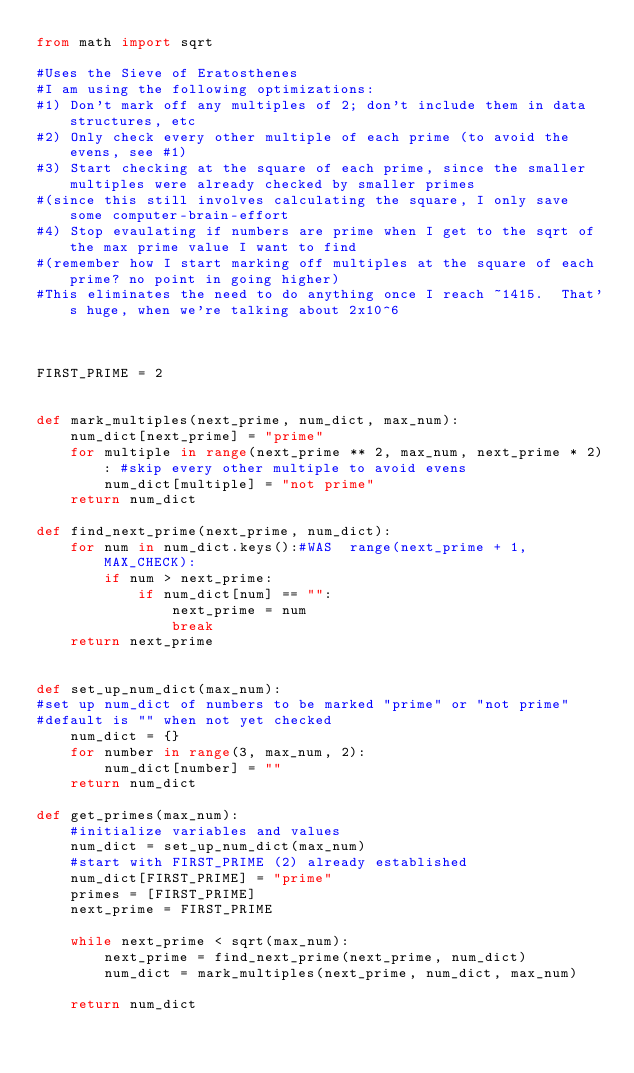Convert code to text. <code><loc_0><loc_0><loc_500><loc_500><_Python_>from math import sqrt

#Uses the Sieve of Eratosthenes
#I am using the following optimizations:
#1) Don't mark off any multiples of 2; don't include them in data structures, etc
#2) Only check every other multiple of each prime (to avoid the evens, see #1)
#3) Start checking at the square of each prime, since the smaller multiples were already checked by smaller primes
#(since this still involves calculating the square, I only save some computer-brain-effort
#4) Stop evaulating if numbers are prime when I get to the sqrt of the max prime value I want to find
#(remember how I start marking off multiples at the square of each prime? no point in going higher)
#This eliminates the need to do anything once I reach ~1415.  That's huge, when we're talking about 2x10^6



FIRST_PRIME = 2


def mark_multiples(next_prime, num_dict, max_num):
    num_dict[next_prime] = "prime"
    for multiple in range(next_prime ** 2, max_num, next_prime * 2): #skip every other multiple to avoid evens
        num_dict[multiple] = "not prime"
    return num_dict

def find_next_prime(next_prime, num_dict):
    for num in num_dict.keys():#WAS  range(next_prime + 1, MAX_CHECK):
        if num > next_prime:
            if num_dict[num] == "":
                next_prime = num
                break
    return next_prime


def set_up_num_dict(max_num):
#set up num_dict of numbers to be marked "prime" or "not prime"
#default is "" when not yet checked
    num_dict = {}
    for number in range(3, max_num, 2):
        num_dict[number] = ""
    return num_dict

def get_primes(max_num):
    #initialize variables and values
    num_dict = set_up_num_dict(max_num)
    #start with FIRST_PRIME (2) already established
    num_dict[FIRST_PRIME] = "prime"
    primes = [FIRST_PRIME]
    next_prime = FIRST_PRIME

    while next_prime < sqrt(max_num):
        next_prime = find_next_prime(next_prime, num_dict)
        num_dict = mark_multiples(next_prime, num_dict, max_num)

    return num_dict

</code> 